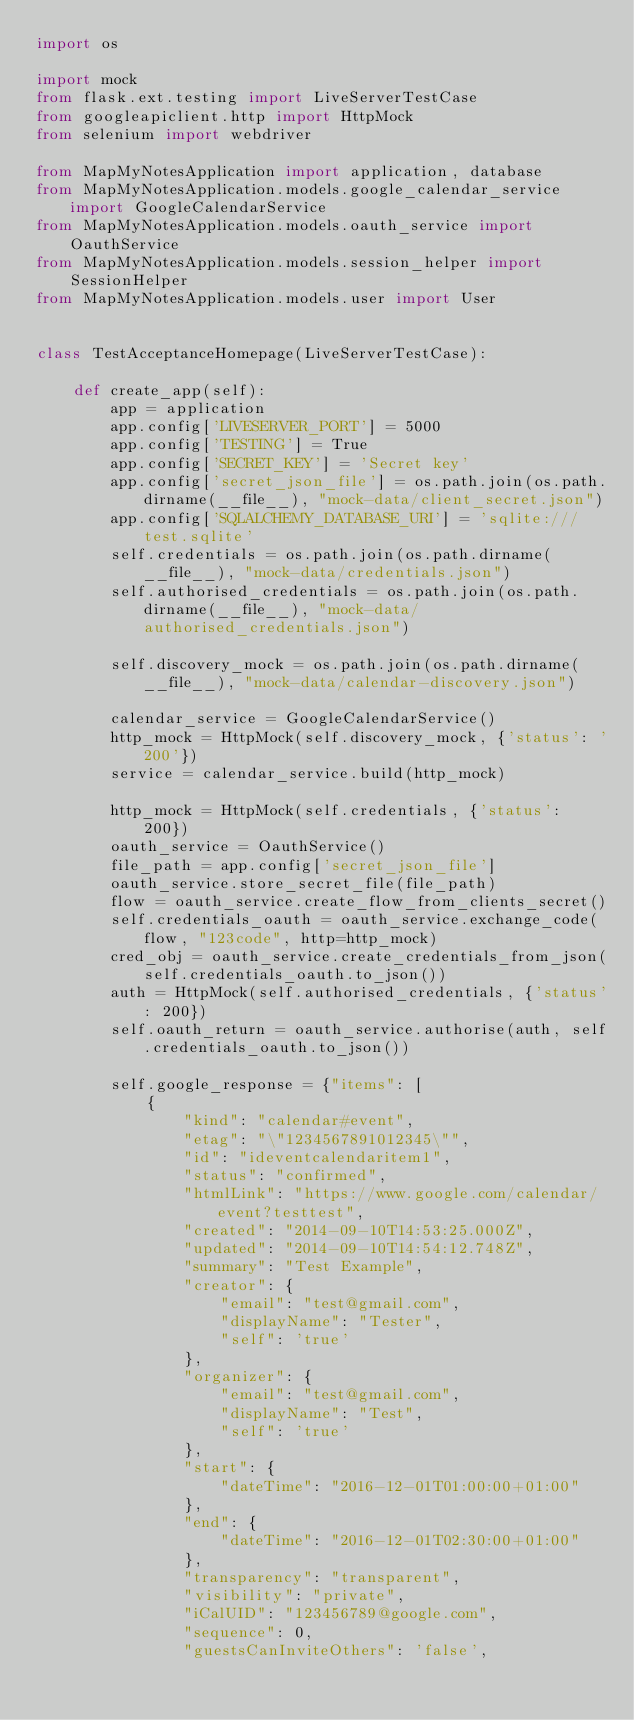<code> <loc_0><loc_0><loc_500><loc_500><_Python_>import os

import mock
from flask.ext.testing import LiveServerTestCase
from googleapiclient.http import HttpMock
from selenium import webdriver

from MapMyNotesApplication import application, database
from MapMyNotesApplication.models.google_calendar_service import GoogleCalendarService
from MapMyNotesApplication.models.oauth_service import OauthService
from MapMyNotesApplication.models.session_helper import SessionHelper
from MapMyNotesApplication.models.user import User


class TestAcceptanceHomepage(LiveServerTestCase):

    def create_app(self):
        app = application
        app.config['LIVESERVER_PORT'] = 5000
        app.config['TESTING'] = True
        app.config['SECRET_KEY'] = 'Secret key'
        app.config['secret_json_file'] = os.path.join(os.path.dirname(__file__), "mock-data/client_secret.json")
        app.config['SQLALCHEMY_DATABASE_URI'] = 'sqlite:///test.sqlite'
        self.credentials = os.path.join(os.path.dirname(__file__), "mock-data/credentials.json")
        self.authorised_credentials = os.path.join(os.path.dirname(__file__), "mock-data/authorised_credentials.json")

        self.discovery_mock = os.path.join(os.path.dirname(__file__), "mock-data/calendar-discovery.json")

        calendar_service = GoogleCalendarService()
        http_mock = HttpMock(self.discovery_mock, {'status': '200'})
        service = calendar_service.build(http_mock)

        http_mock = HttpMock(self.credentials, {'status': 200})
        oauth_service = OauthService()
        file_path = app.config['secret_json_file']
        oauth_service.store_secret_file(file_path)
        flow = oauth_service.create_flow_from_clients_secret()
        self.credentials_oauth = oauth_service.exchange_code(flow, "123code", http=http_mock)
        cred_obj = oauth_service.create_credentials_from_json(self.credentials_oauth.to_json())
        auth = HttpMock(self.authorised_credentials, {'status': 200})
        self.oauth_return = oauth_service.authorise(auth, self.credentials_oauth.to_json())

        self.google_response = {"items": [
            {
                "kind": "calendar#event",
                "etag": "\"1234567891012345\"",
                "id": "ideventcalendaritem1",
                "status": "confirmed",
                "htmlLink": "https://www.google.com/calendar/event?testtest",
                "created": "2014-09-10T14:53:25.000Z",
                "updated": "2014-09-10T14:54:12.748Z",
                "summary": "Test Example",
                "creator": {
                    "email": "test@gmail.com",
                    "displayName": "Tester",
                    "self": 'true'
                },
                "organizer": {
                    "email": "test@gmail.com",
                    "displayName": "Test",
                    "self": 'true'
                },
                "start": {
                    "dateTime": "2016-12-01T01:00:00+01:00"
                },
                "end": {
                    "dateTime": "2016-12-01T02:30:00+01:00"
                },
                "transparency": "transparent",
                "visibility": "private",
                "iCalUID": "123456789@google.com",
                "sequence": 0,
                "guestsCanInviteOthers": 'false',</code> 